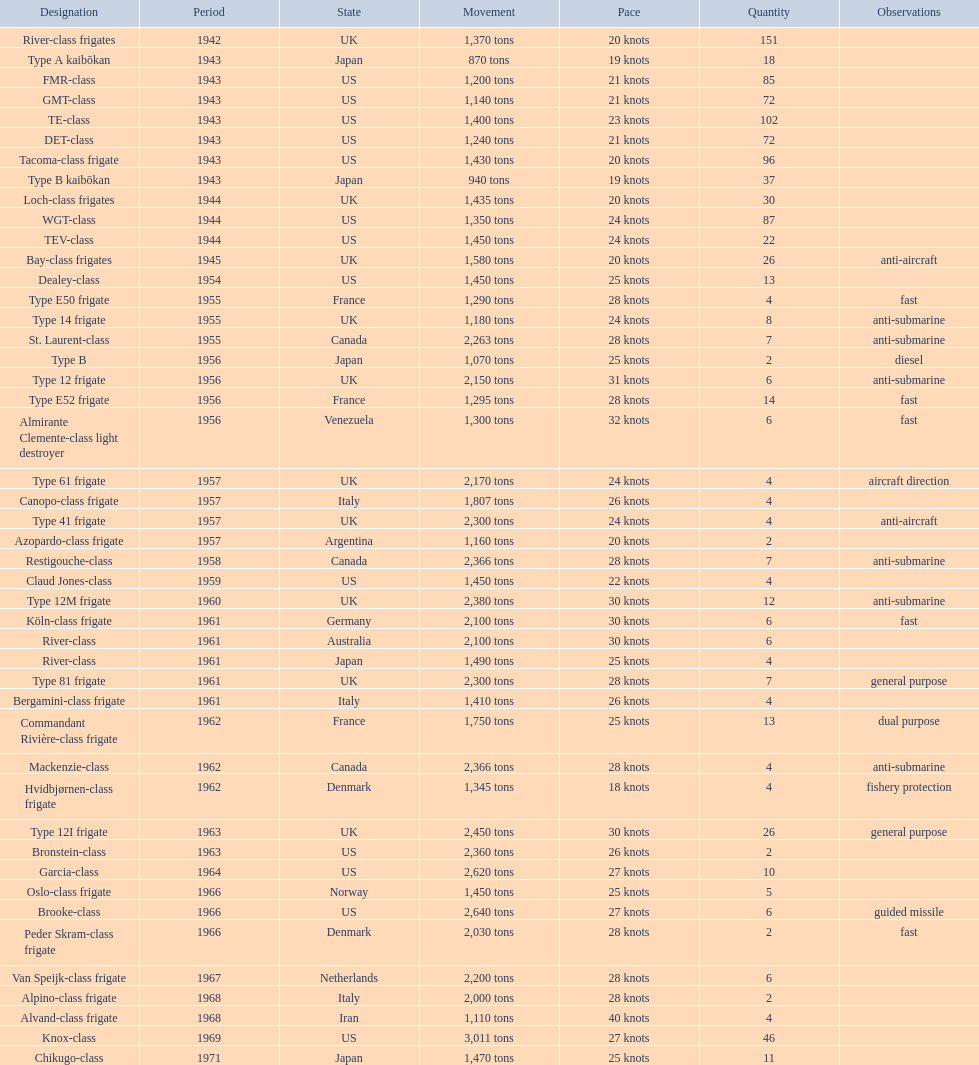How many tons does the te-class displace? 1,400 tons. 